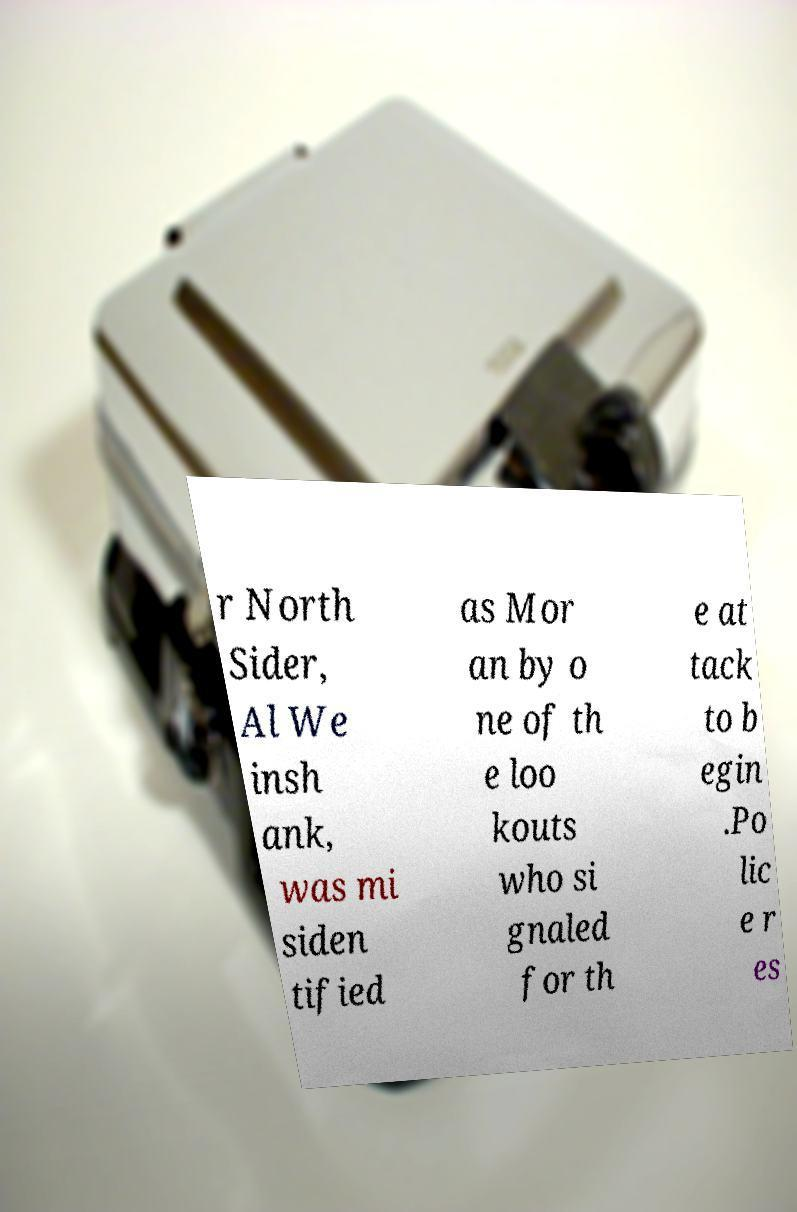For documentation purposes, I need the text within this image transcribed. Could you provide that? r North Sider, Al We insh ank, was mi siden tified as Mor an by o ne of th e loo kouts who si gnaled for th e at tack to b egin .Po lic e r es 